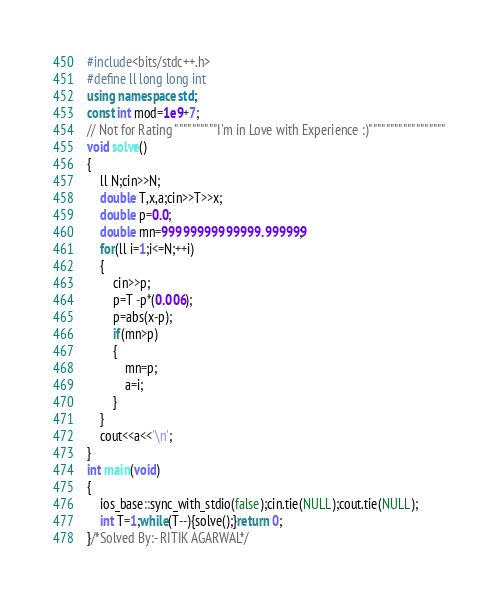Convert code to text. <code><loc_0><loc_0><loc_500><loc_500><_C++_>#include<bits/stdc++.h>
#define ll long long int
using namespace std;
const int mod=1e9+7;
// Not for Rating """"""""""I'm in Love with Experience :)""""""""""""""""""
void solve()
{
    ll N;cin>>N;
    double T,x,a;cin>>T>>x;
    double p=0.0;
    double mn=99999999999999.999999;
    for(ll i=1;i<=N;++i)
    {
        cin>>p;
        p=T -p*(0.006);
        p=abs(x-p);
        if(mn>p)
        {
            mn=p;
            a=i;
        }
    }
    cout<<a<<'\n';
}
int main(void)
{
    ios_base::sync_with_stdio(false);cin.tie(NULL);cout.tie(NULL);
    int T=1;while(T--){solve();}return 0;
}/*Solved By:- RITIK AGARWAL*/</code> 